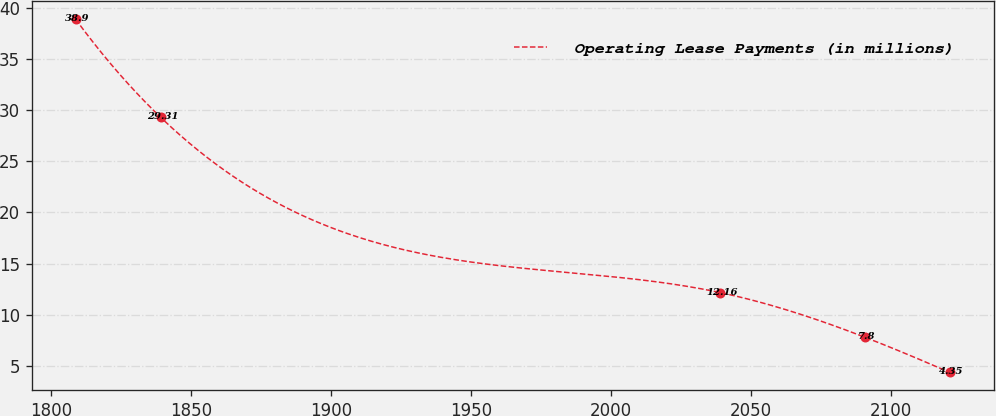Convert chart to OTSL. <chart><loc_0><loc_0><loc_500><loc_500><line_chart><ecel><fcel>Operating Lease Payments (in millions)<nl><fcel>1808.79<fcel>38.9<nl><fcel>1839.17<fcel>29.31<nl><fcel>2039.18<fcel>12.16<nl><fcel>2090.77<fcel>7.8<nl><fcel>2121.15<fcel>4.35<nl></chart> 